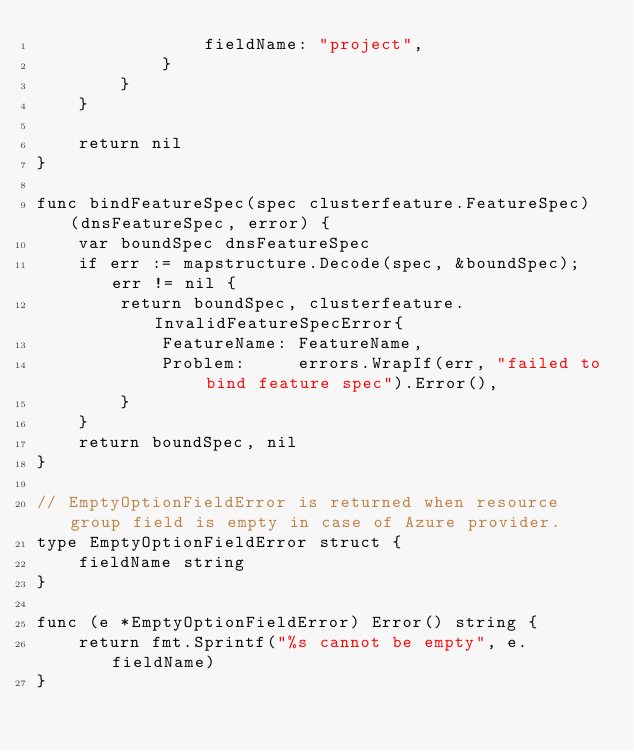Convert code to text. <code><loc_0><loc_0><loc_500><loc_500><_Go_>				fieldName: "project",
			}
		}
	}

	return nil
}

func bindFeatureSpec(spec clusterfeature.FeatureSpec) (dnsFeatureSpec, error) {
	var boundSpec dnsFeatureSpec
	if err := mapstructure.Decode(spec, &boundSpec); err != nil {
		return boundSpec, clusterfeature.InvalidFeatureSpecError{
			FeatureName: FeatureName,
			Problem:     errors.WrapIf(err, "failed to bind feature spec").Error(),
		}
	}
	return boundSpec, nil
}

// EmptyOptionFieldError is returned when resource group field is empty in case of Azure provider.
type EmptyOptionFieldError struct {
	fieldName string
}

func (e *EmptyOptionFieldError) Error() string {
	return fmt.Sprintf("%s cannot be empty", e.fieldName)
}
</code> 